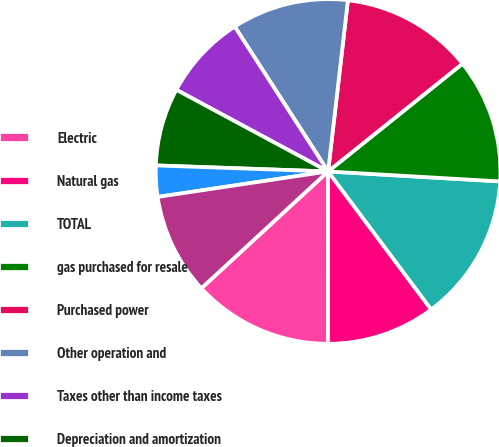Convert chart. <chart><loc_0><loc_0><loc_500><loc_500><pie_chart><fcel>Electric<fcel>Natural gas<fcel>TOTAL<fcel>gas purchased for resale<fcel>Purchased power<fcel>Other operation and<fcel>Taxes other than income taxes<fcel>Depreciation and amortization<fcel>Other regulatory charges<fcel>OPERATING INCOME<nl><fcel>13.14%<fcel>10.22%<fcel>13.87%<fcel>11.68%<fcel>12.41%<fcel>10.95%<fcel>8.03%<fcel>7.3%<fcel>2.92%<fcel>9.49%<nl></chart> 